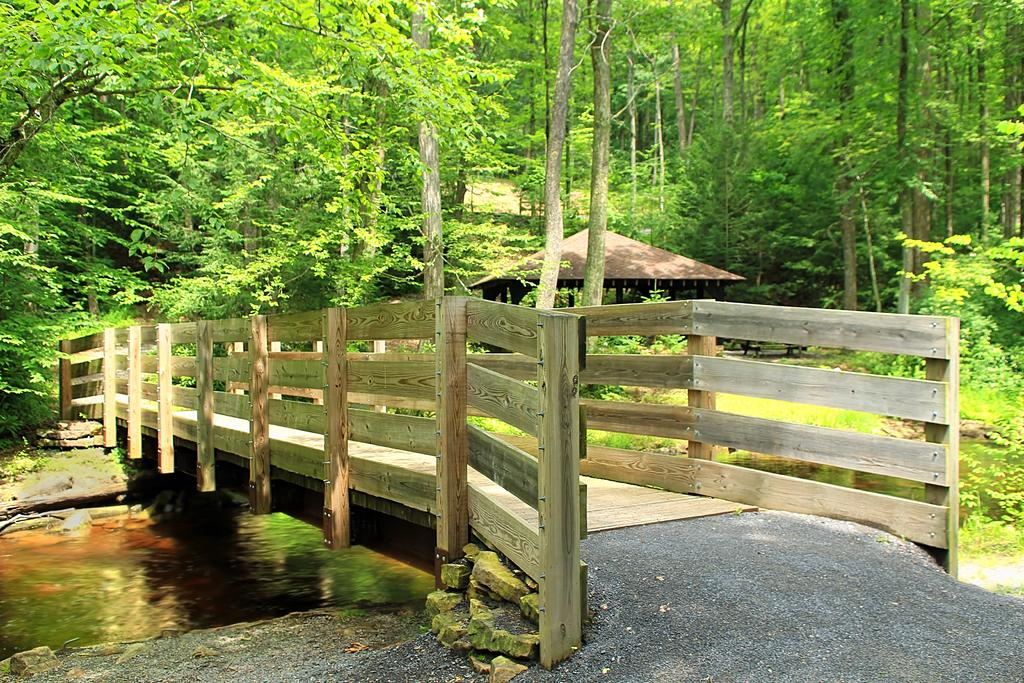What can be seen on the left side of the image? There is water on the left side of the image. What structure is located in the middle of the image? There is a bridge in the middle of the image. What type of vegetation is visible in the background of the image? There are trees in the background of the image. What type of building can be seen in the background? There is a hut in the background of the image. Reasoning: Let' Let's think step by step in order to produce the conversation. We start by identifying the main subjects and objects in the image based on the provided facts. We then formulate questions that focus on the location and characteristics of these subjects and objects, ensuring that each question can be answered definitively with the information given. We avoid yes/no questions and ensure that the language is simple and clear. Absurd Question/Answer: What brand of toothpaste is advertised on the bridge in the image? There is no toothpaste or advertisement present on the bridge in the image. What emotion is the person in the image feeling, given the presence of regret? There is no person or emotion mentioned in the image, and regret is not a visible element. 